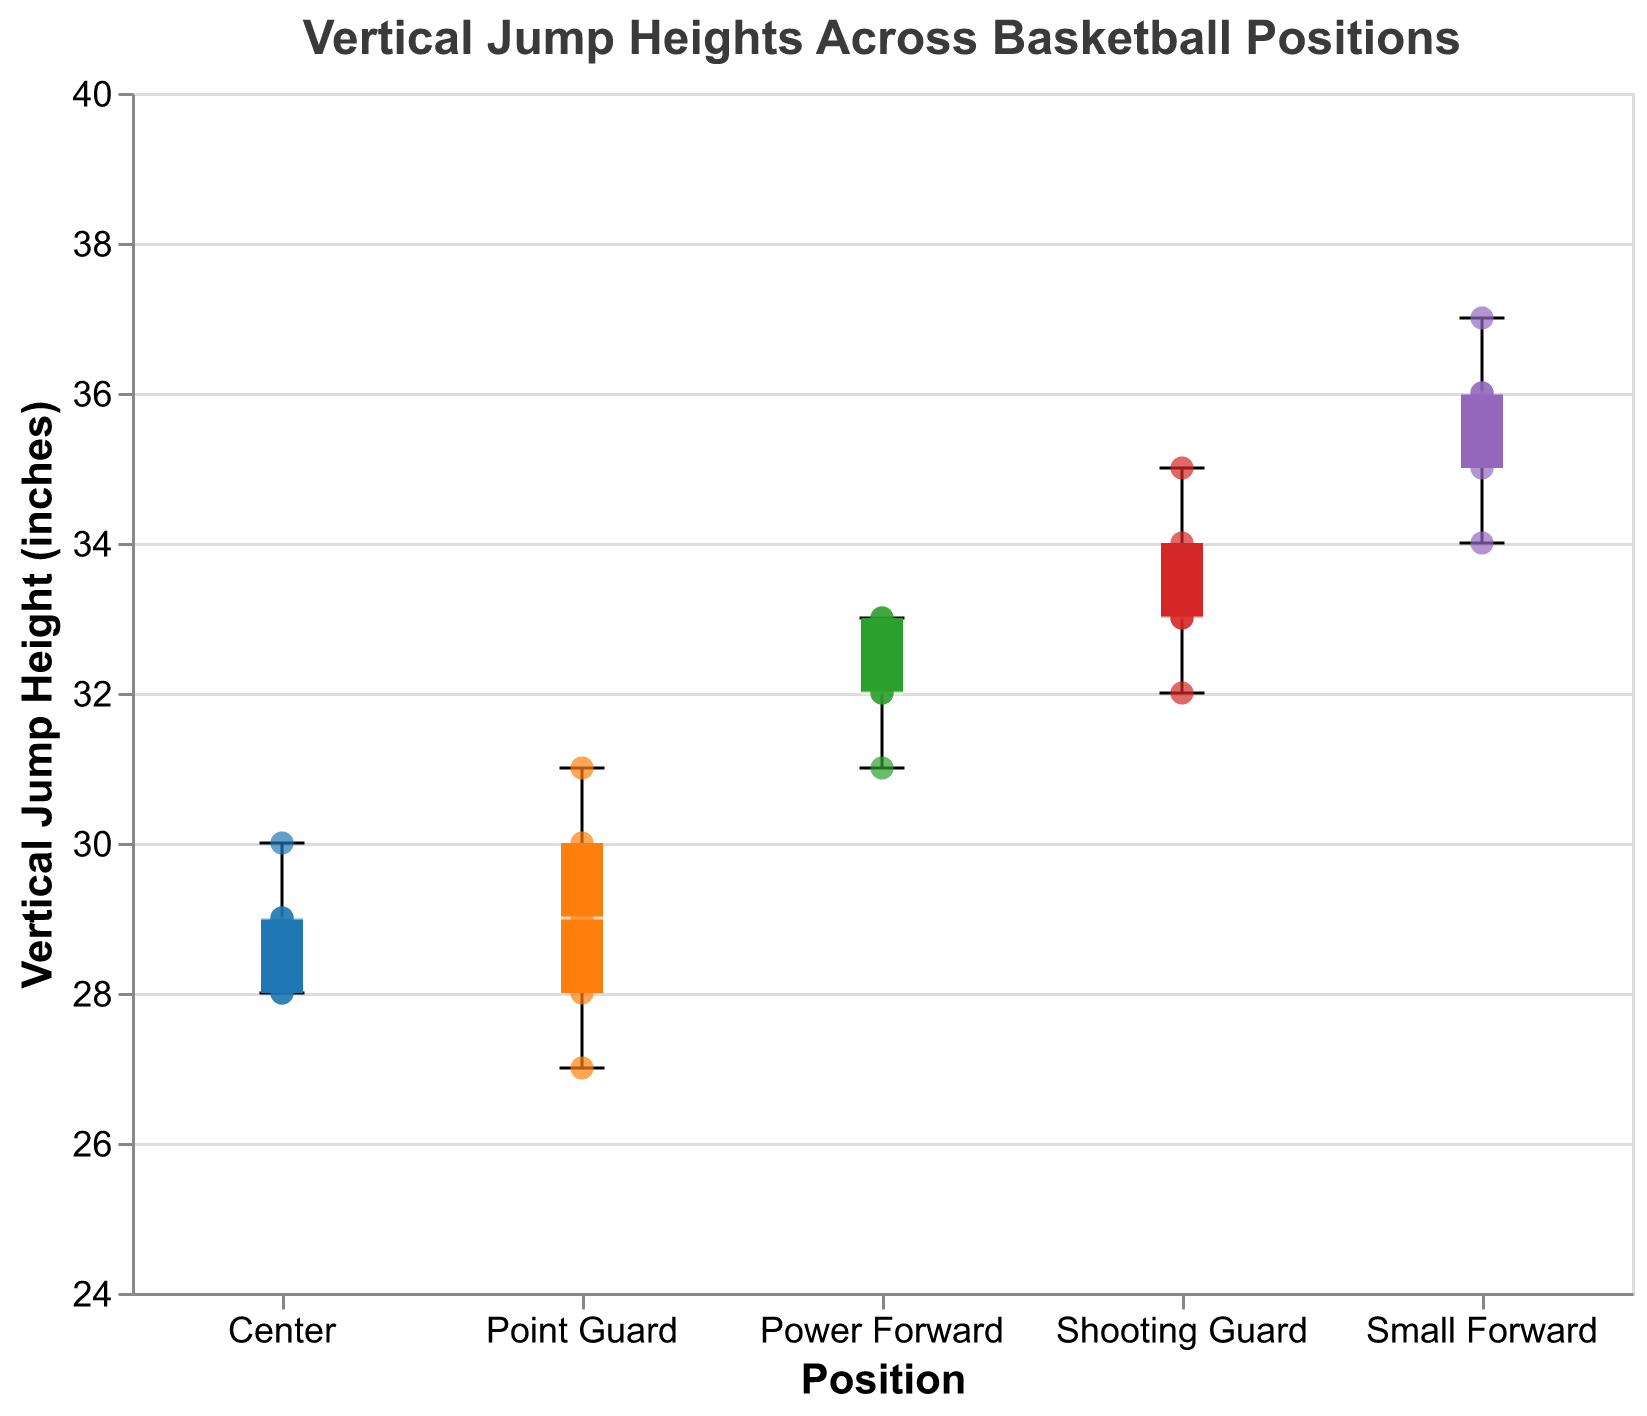What is the title of the figure? The title is displayed at the top of the figure and summarizes the content of the plot.
Answer: Vertical Jump Heights Across Basketball Positions What does the y-axis represent? The y-axis title is labeled on the left side of the plot, specifying that it represents the measurement unit and the data type.
Answer: Vertical Jump Height (inches) How many Point Guard players have their vertical jump heights marked with scatter points? Count the number of individual scatter points within the "Point Guard" category on the x-axis.
Answer: 5 Which player has the highest vertical jump height among the Centers? Look for the individual scatter point with the highest position within the "Center" box plot.
Answer: Matthew Adams Which position has the widest range of vertical jump heights? Compare the range of the box plots (difference between the highest and lowest points) for all positions.
Answer: Point Guard What is the median vertical jump height for Small Forwards? Locate the white median line within the "Small Forward" box plot.
Answer: 36 inches How does the median vertical jump height for Power Forwards compare to that of Centers? Look at the median lines of the "Power Forward" and "Center" box plots and compare their heights on the y-axis.
Answer: Higher for Power Forwards What is the interquartile range (IQR) for the Shooting Guards' vertical jump heights? Find the upper quartile (top of the box) and lower quartile (bottom of the box) within the "Shooting Guard" box plot and calculate the difference.
Answer: 34 - 32 = 2 inches Which position has at least one player with a vertical jump height of 28 inches? Check each position's scatter points to identify where any data points appear at the 28-inch mark.
Answer: Point Guard, Center 